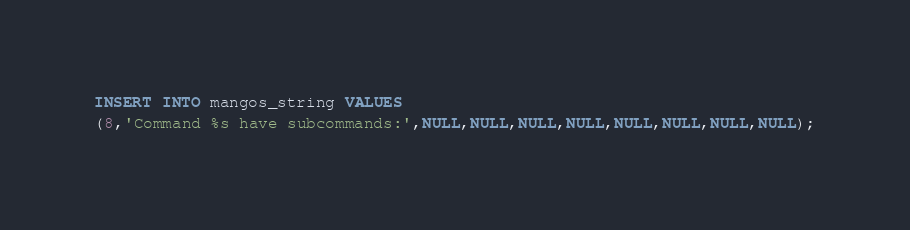<code> <loc_0><loc_0><loc_500><loc_500><_SQL_>INSERT INTO mangos_string VALUES
(8,'Command %s have subcommands:',NULL,NULL,NULL,NULL,NULL,NULL,NULL,NULL);
</code> 